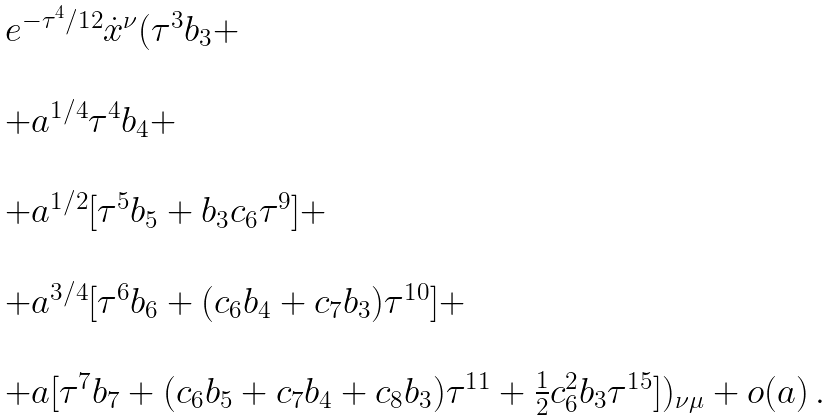Convert formula to latex. <formula><loc_0><loc_0><loc_500><loc_500>\begin{array} { l l l } & & e ^ { - \tau ^ { 4 } / 1 2 } \dot { x } ^ { \nu } ( \tau ^ { 3 } b _ { 3 } + \\ & & \\ & & + a ^ { 1 / 4 } \tau ^ { 4 } b _ { 4 } + \\ & & \\ & & + a ^ { 1 / 2 } [ \tau ^ { 5 } b _ { 5 } + b _ { 3 } c _ { 6 } \tau ^ { 9 } ] + \\ & & \\ & & + a ^ { 3 / 4 } [ \tau ^ { 6 } b _ { 6 } + ( c _ { 6 } b _ { 4 } + c _ { 7 } b _ { 3 } ) \tau ^ { 1 0 } ] + \\ & & \\ & & + a [ \tau ^ { 7 } b _ { 7 } + ( c _ { 6 } b _ { 5 } + c _ { 7 } b _ { 4 } + c _ { 8 } b _ { 3 } ) \tau ^ { 1 1 } + \frac { 1 } { 2 } c _ { 6 } ^ { 2 } b _ { 3 } \tau ^ { 1 5 } ] ) _ { \nu \mu } + o ( a ) \, . \end{array}</formula> 